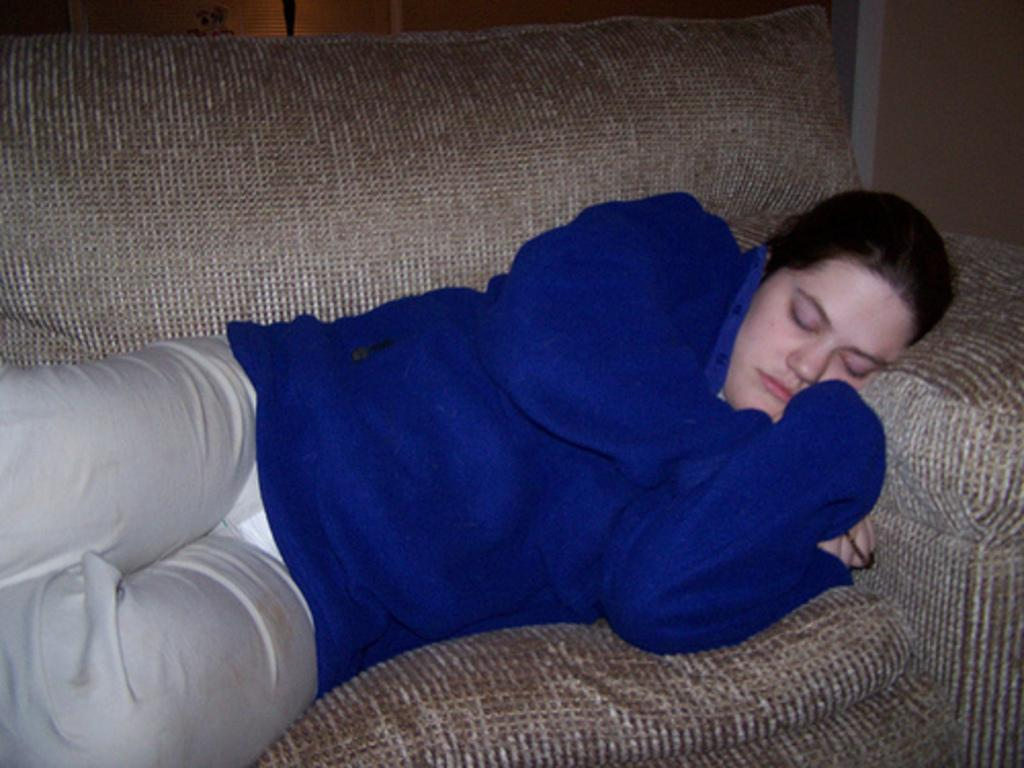Who is the main subject in the foreground of the picture? There is a woman in the foreground of the picture. What is the woman wearing in the image? The woman is wearing a blue coat. What is the woman doing in the picture? The woman is sleeping on a couch. What can be seen in the background of the picture? There is a wall and a window blind in the background of the picture. Can you see a zebra or a deer in the image? No, there are no zebras or deer present in the image. What type of horn is visible on the woman's head in the image? There is no horn visible on the woman's head in the image. 